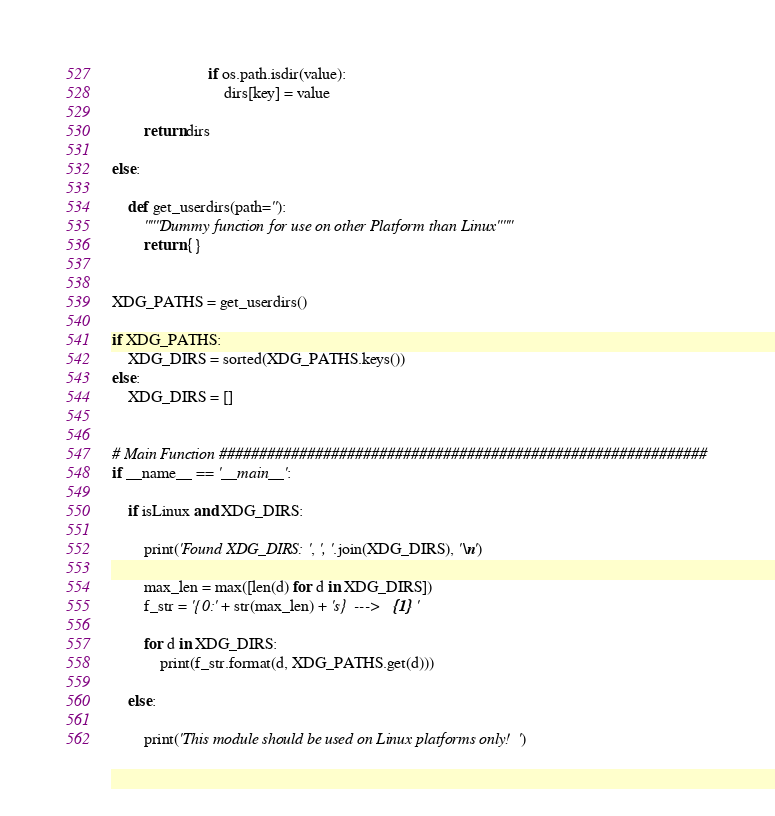Convert code to text. <code><loc_0><loc_0><loc_500><loc_500><_Python_>                        if os.path.isdir(value):
                            dirs[key] = value

        return dirs

else:

    def get_userdirs(path=''):
        """Dummy function for use on other Platform than Linux"""
        return {}


XDG_PATHS = get_userdirs()

if XDG_PATHS:
    XDG_DIRS = sorted(XDG_PATHS.keys())
else:
    XDG_DIRS = []


# Main Function #############################################################
if __name__ == '__main__':

    if isLinux and XDG_DIRS:

        print('Found XDG_DIRS:', ', '.join(XDG_DIRS), '\n')

        max_len = max([len(d) for d in XDG_DIRS])
        f_str = '{0:' + str(max_len) + 's}  --->   {1}'

        for d in XDG_DIRS:
            print(f_str.format(d, XDG_PATHS.get(d)))

    else:

        print('This module should be used on Linux platforms only!')
</code> 